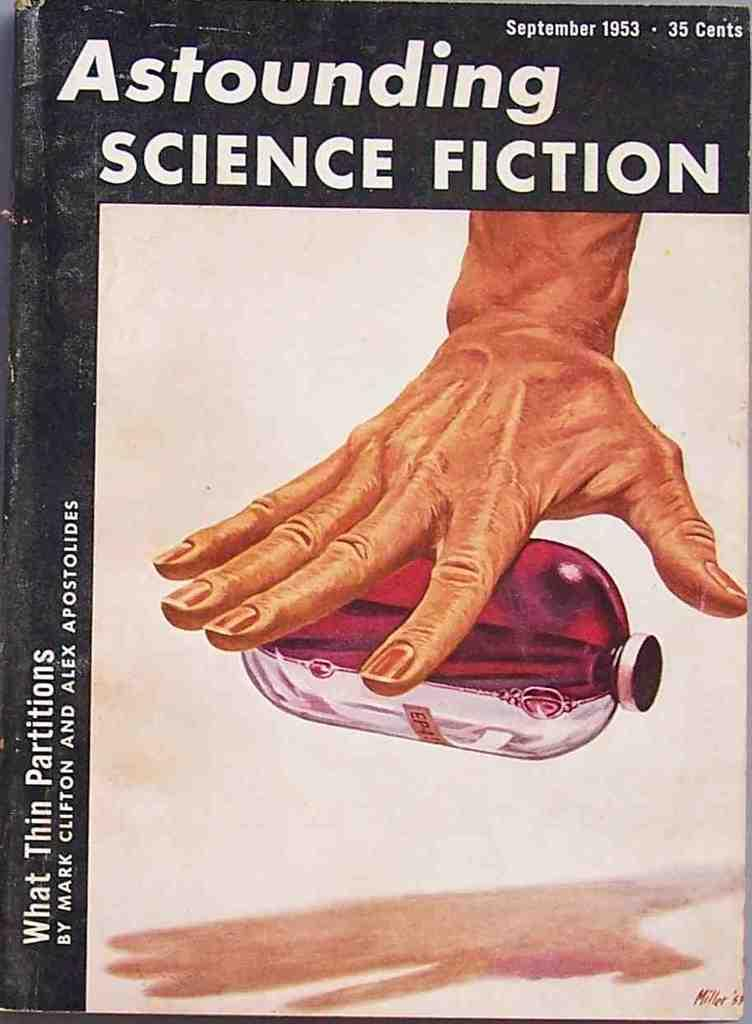<image>
Relay a brief, clear account of the picture shown. a book from 1953 called astounding science fiction has a picture of a hand on it 